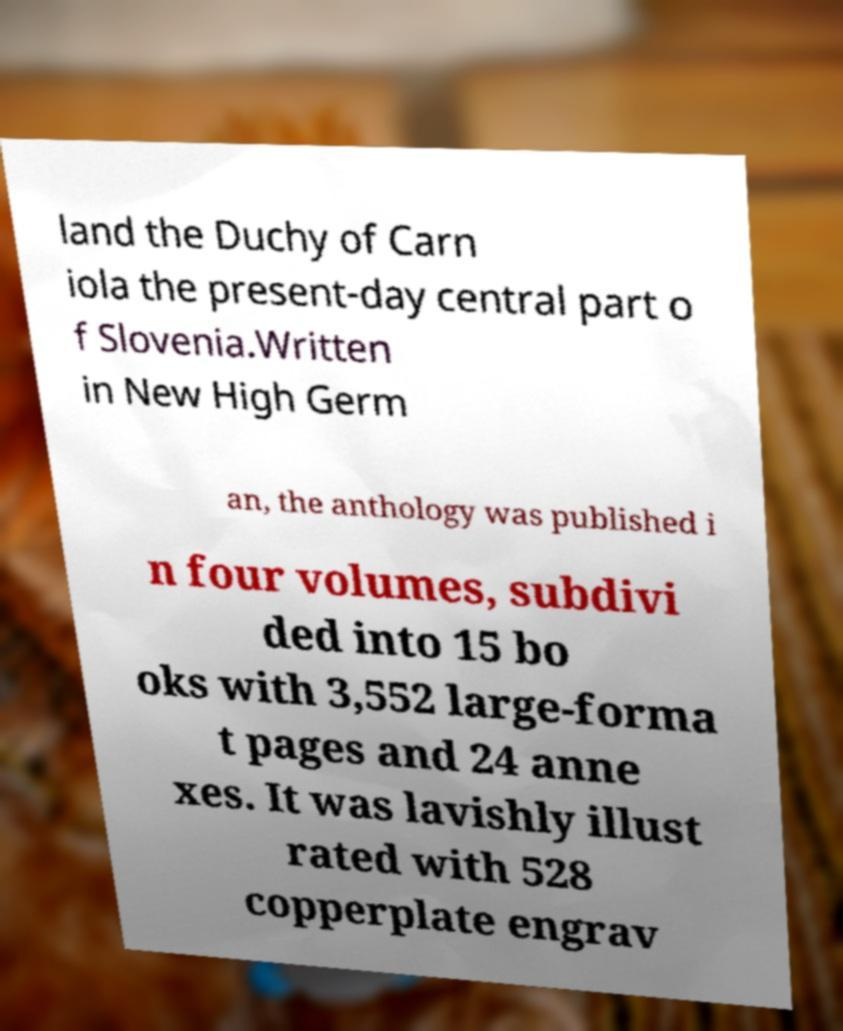Can you read and provide the text displayed in the image?This photo seems to have some interesting text. Can you extract and type it out for me? land the Duchy of Carn iola the present-day central part o f Slovenia.Written in New High Germ an, the anthology was published i n four volumes, subdivi ded into 15 bo oks with 3,552 large-forma t pages and 24 anne xes. It was lavishly illust rated with 528 copperplate engrav 